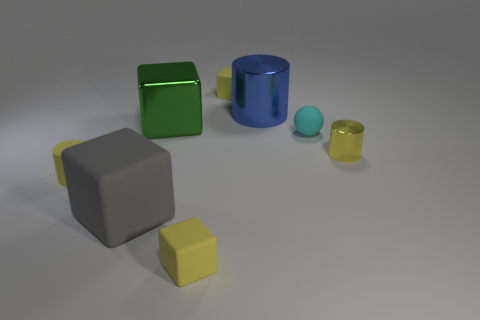What material is the cylinder that is the same color as the tiny shiny thing?
Give a very brief answer. Rubber. Are there any small yellow rubber cubes?
Your response must be concise. Yes. Is there another tiny sphere that has the same material as the cyan ball?
Keep it short and to the point. No. There is a cyan thing that is the same size as the yellow rubber cylinder; what is it made of?
Ensure brevity in your answer.  Rubber. How many tiny yellow shiny objects are the same shape as the big blue thing?
Provide a short and direct response. 1. What size is the yellow thing that is made of the same material as the big cylinder?
Offer a very short reply. Small. The block that is both in front of the blue shiny thing and behind the tiny metallic cylinder is made of what material?
Make the answer very short. Metal. What number of matte cylinders are the same size as the cyan rubber thing?
Ensure brevity in your answer.  1. What material is the other small yellow object that is the same shape as the tiny yellow metal thing?
Ensure brevity in your answer.  Rubber. What number of objects are either matte things behind the big green object or matte cubes to the left of the large green shiny object?
Provide a succinct answer. 2. 